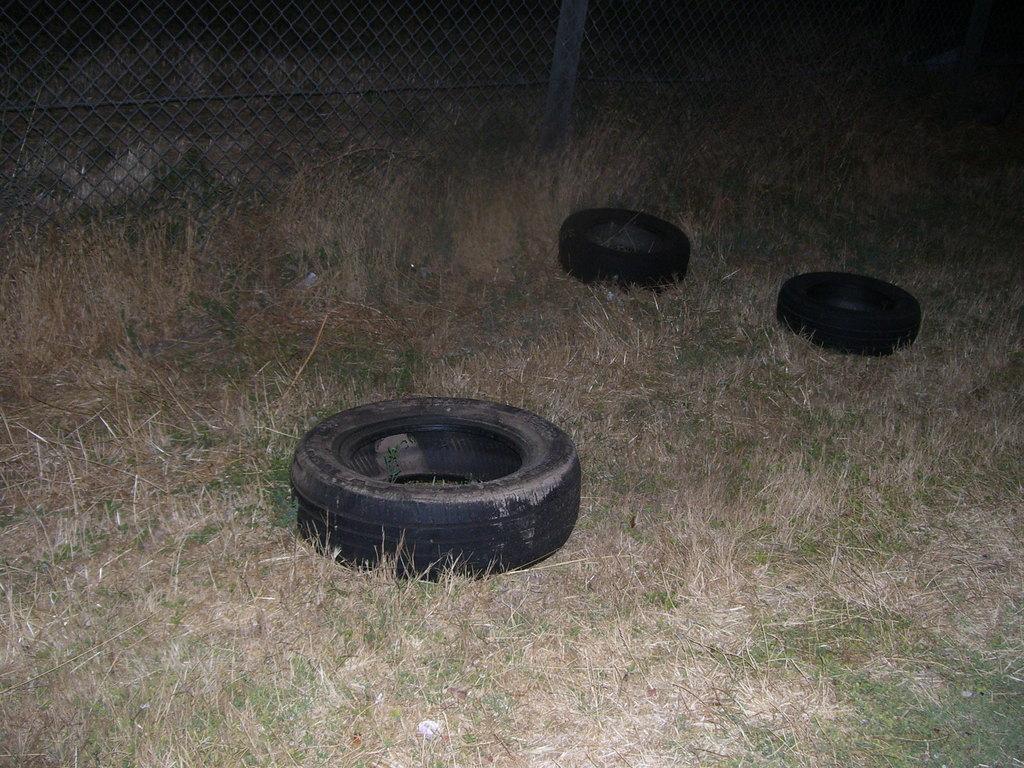How would you summarize this image in a sentence or two? In the foreground of the picture there are tyres, grass and dry grass. In the background it is fencing. Outside the fencing there is grass. 